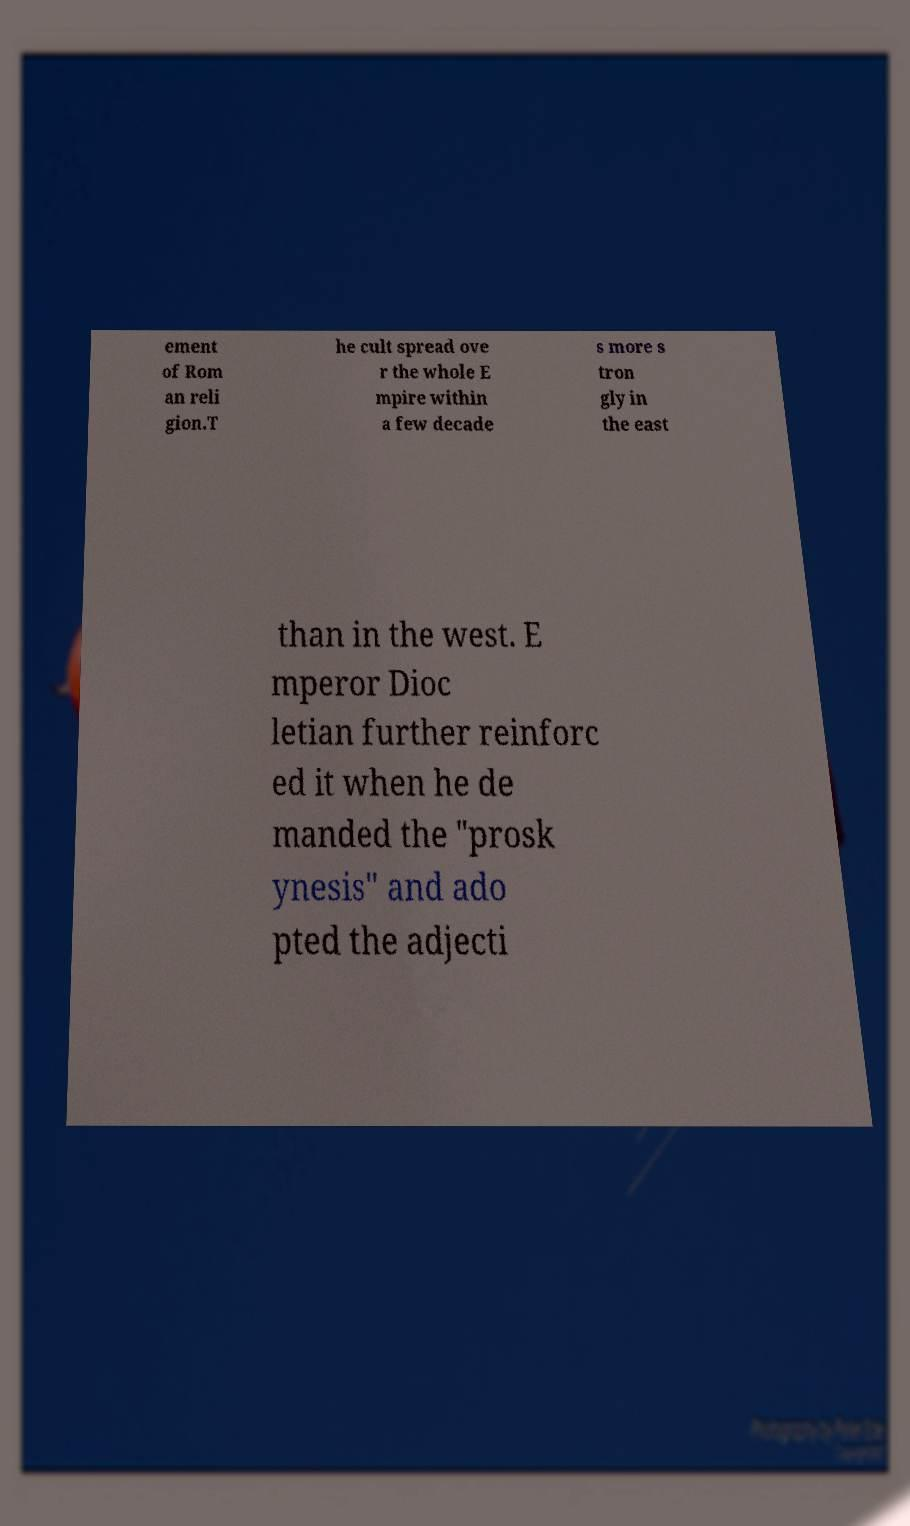What messages or text are displayed in this image? I need them in a readable, typed format. ement of Rom an reli gion.T he cult spread ove r the whole E mpire within a few decade s more s tron gly in the east than in the west. E mperor Dioc letian further reinforc ed it when he de manded the "prosk ynesis" and ado pted the adjecti 